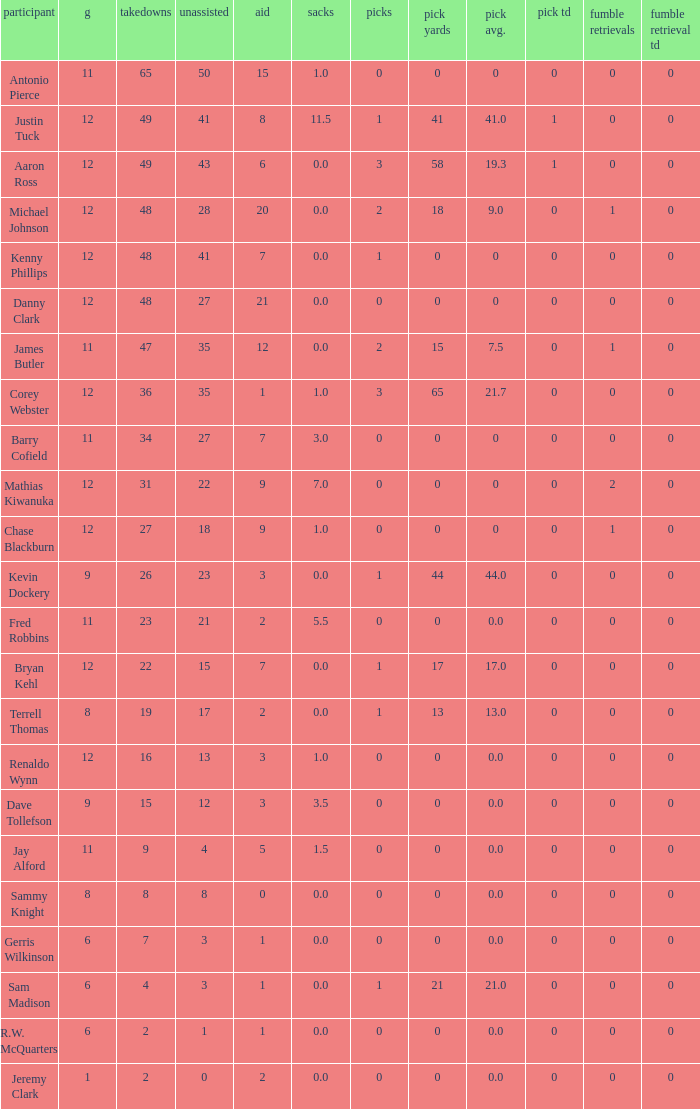Name the least amount of int yards 0.0. 